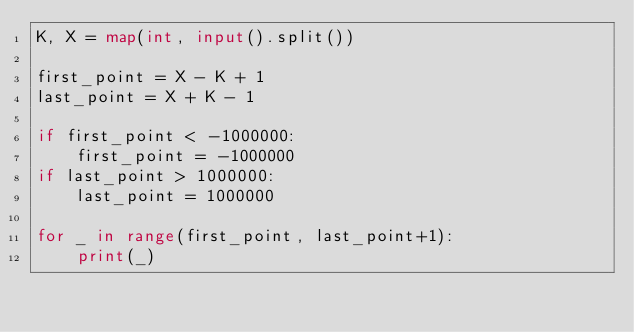Convert code to text. <code><loc_0><loc_0><loc_500><loc_500><_Python_>K, X = map(int, input().split())

first_point = X - K + 1
last_point = X + K - 1

if first_point < -1000000:
    first_point = -1000000
if last_point > 1000000:
    last_point = 1000000

for _ in range(first_point, last_point+1):
    print(_)
</code> 